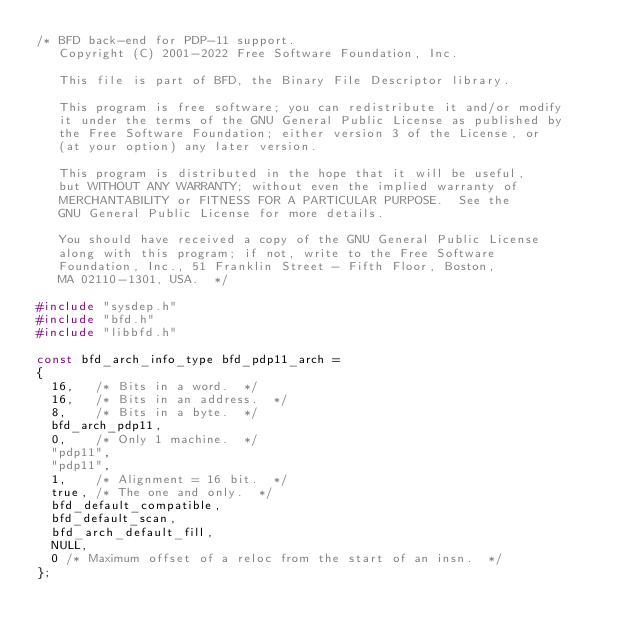<code> <loc_0><loc_0><loc_500><loc_500><_C_>/* BFD back-end for PDP-11 support.
   Copyright (C) 2001-2022 Free Software Foundation, Inc.

   This file is part of BFD, the Binary File Descriptor library.

   This program is free software; you can redistribute it and/or modify
   it under the terms of the GNU General Public License as published by
   the Free Software Foundation; either version 3 of the License, or
   (at your option) any later version.

   This program is distributed in the hope that it will be useful,
   but WITHOUT ANY WARRANTY; without even the implied warranty of
   MERCHANTABILITY or FITNESS FOR A PARTICULAR PURPOSE.  See the
   GNU General Public License for more details.

   You should have received a copy of the GNU General Public License
   along with this program; if not, write to the Free Software
   Foundation, Inc., 51 Franklin Street - Fifth Floor, Boston,
   MA 02110-1301, USA.  */

#include "sysdep.h"
#include "bfd.h"
#include "libbfd.h"

const bfd_arch_info_type bfd_pdp11_arch =
{
  16,	/* Bits in a word.  */
  16,	/* Bits in an address.  */
  8,	/* Bits in a byte.  */
  bfd_arch_pdp11,
  0,	/* Only 1 machine.  */
  "pdp11",
  "pdp11",
  1,	/* Alignment = 16 bit.  */
  true, /* The one and only.  */
  bfd_default_compatible,
  bfd_default_scan,
  bfd_arch_default_fill,
  NULL,
  0 /* Maximum offset of a reloc from the start of an insn.  */
};

</code> 